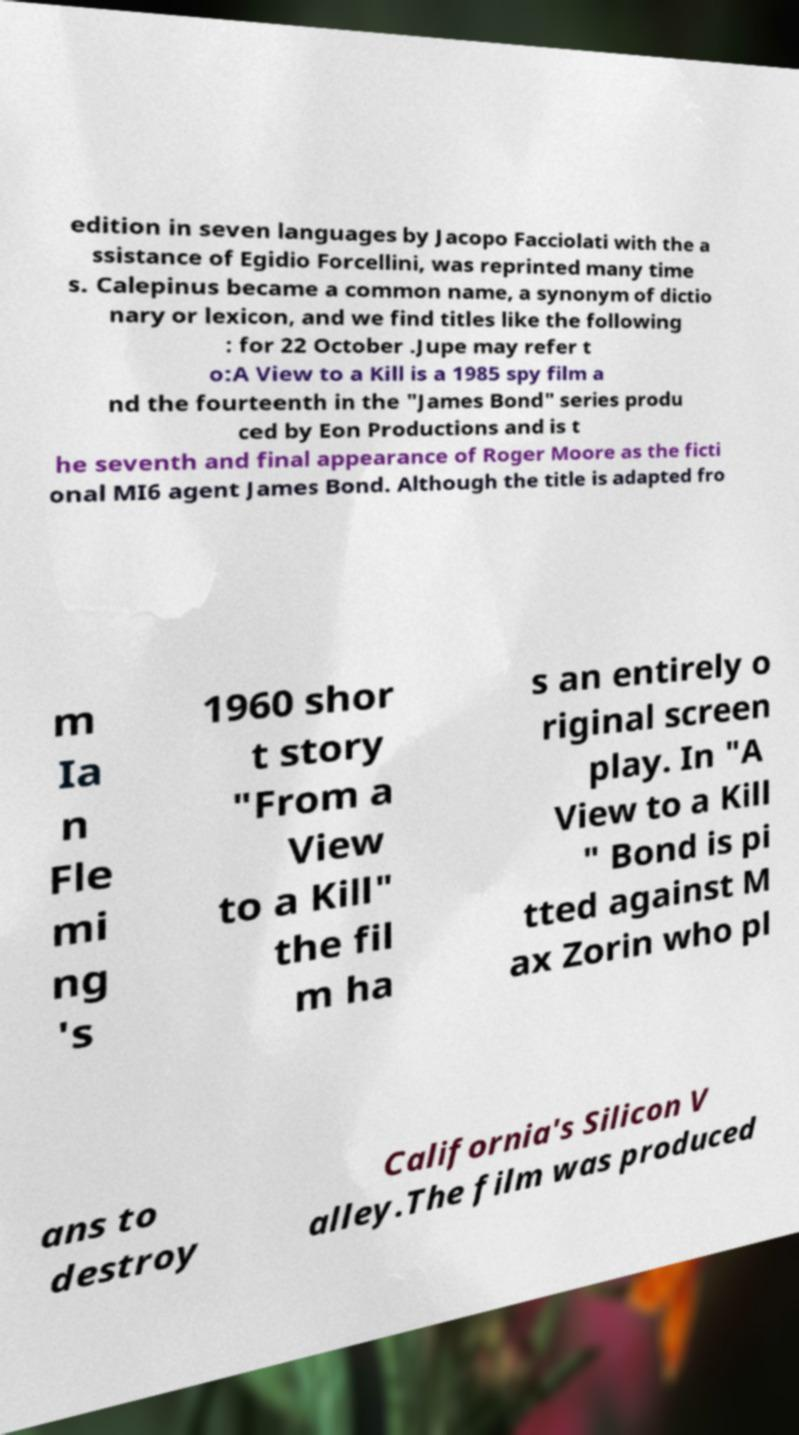I need the written content from this picture converted into text. Can you do that? edition in seven languages by Jacopo Facciolati with the a ssistance of Egidio Forcellini, was reprinted many time s. Calepinus became a common name, a synonym of dictio nary or lexicon, and we find titles like the following : for 22 October .Jupe may refer t o:A View to a Kill is a 1985 spy film a nd the fourteenth in the "James Bond" series produ ced by Eon Productions and is t he seventh and final appearance of Roger Moore as the ficti onal MI6 agent James Bond. Although the title is adapted fro m Ia n Fle mi ng 's 1960 shor t story "From a View to a Kill" the fil m ha s an entirely o riginal screen play. In "A View to a Kill " Bond is pi tted against M ax Zorin who pl ans to destroy California's Silicon V alley.The film was produced 